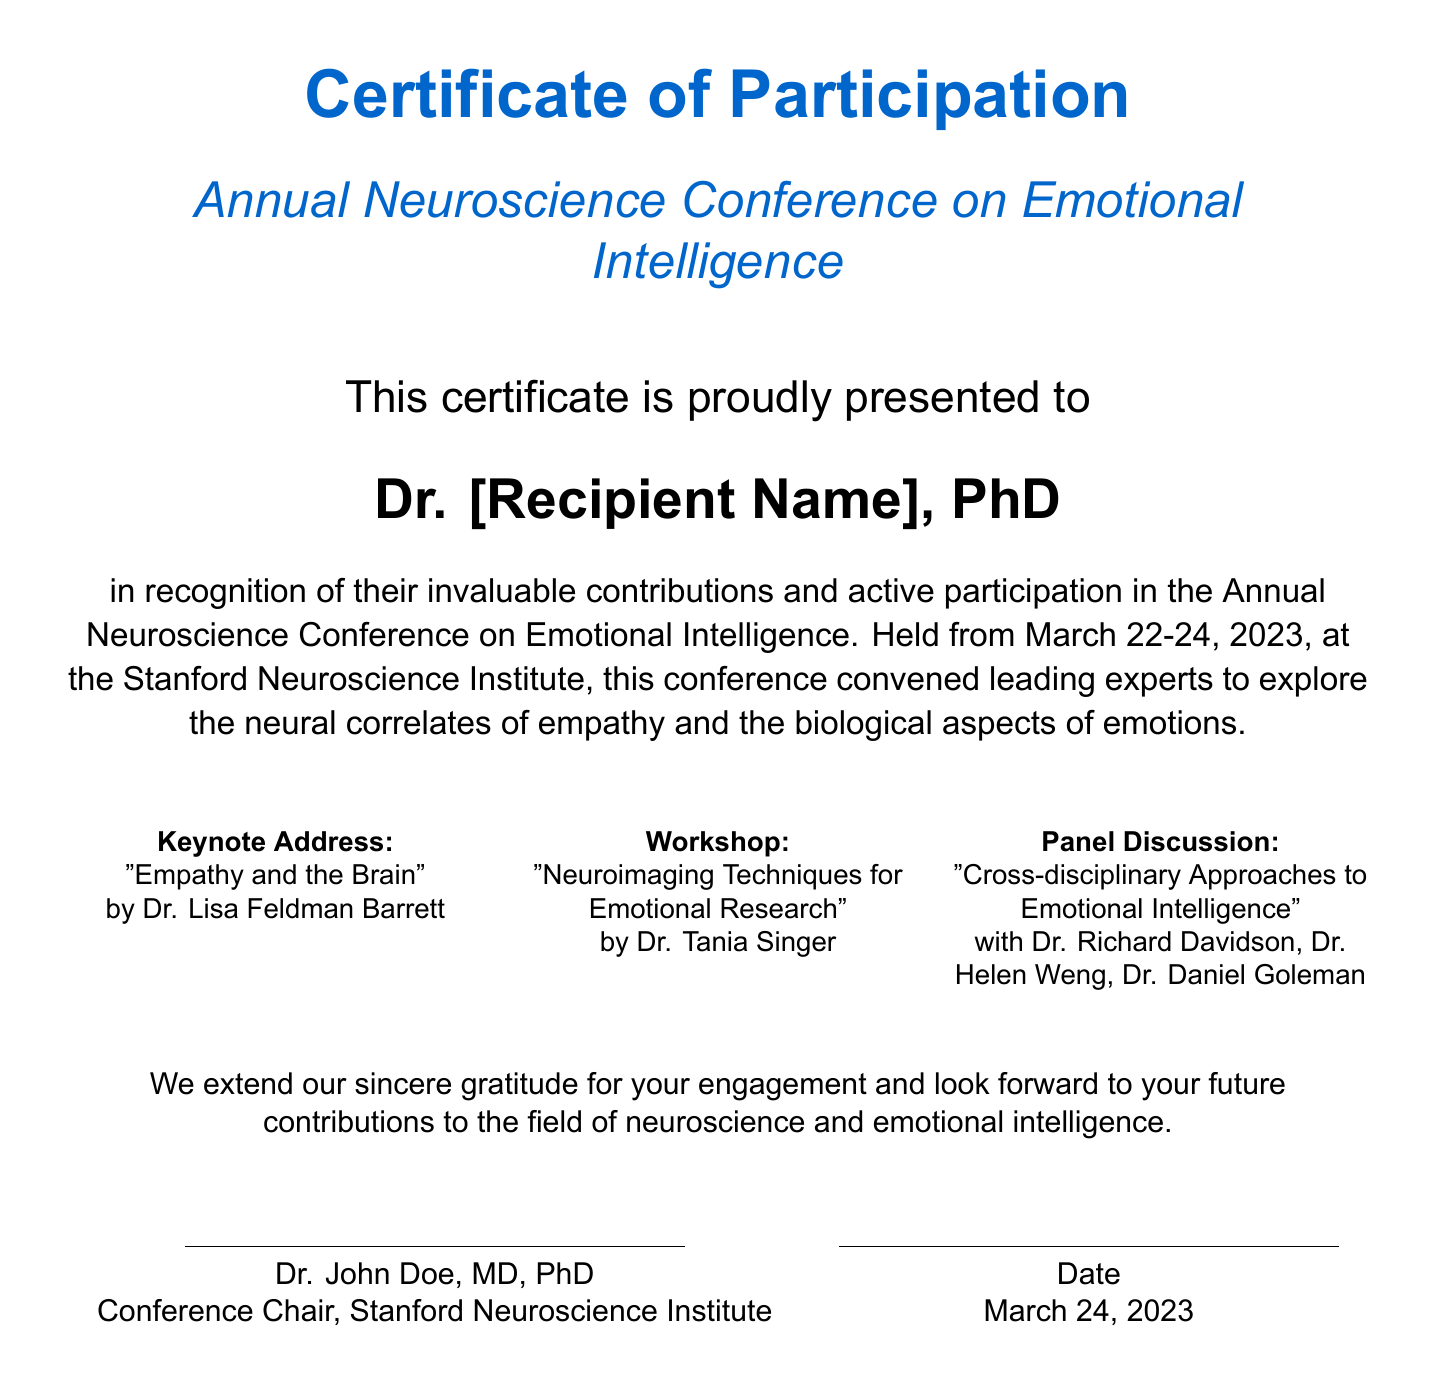what is the title of the certificate? The title of the certificate is prominently stated at the top of the document.
Answer: Certificate of Participation who presented this certificate? The name of the individual presenting the certificate is noted at the bottom of the document.
Answer: Dr. John Doe, MD, PhD what were the dates of the conference? The dates of the conference are specified in the description of the participation.
Answer: March 22-24, 2023 where was the conference held? The venue of the conference is mentioned in the introductory statement.
Answer: Stanford Neuroscience Institute who delivered the keynote address? The name of the individual giving the keynote address is listed in the document.
Answer: Dr. Lisa Feldman Barrett name one topic of the workshop. The document includes specific topics for workshops, one of which is identified.
Answer: Neuroimaging Techniques for Emotional Research what type of event is this document representing? The nature of the event is inferred from the title and content of the document.
Answer: Conference how many keynote speakers were mentioned? The document lists keynote addresses, which can be counted for the answer.
Answer: One 